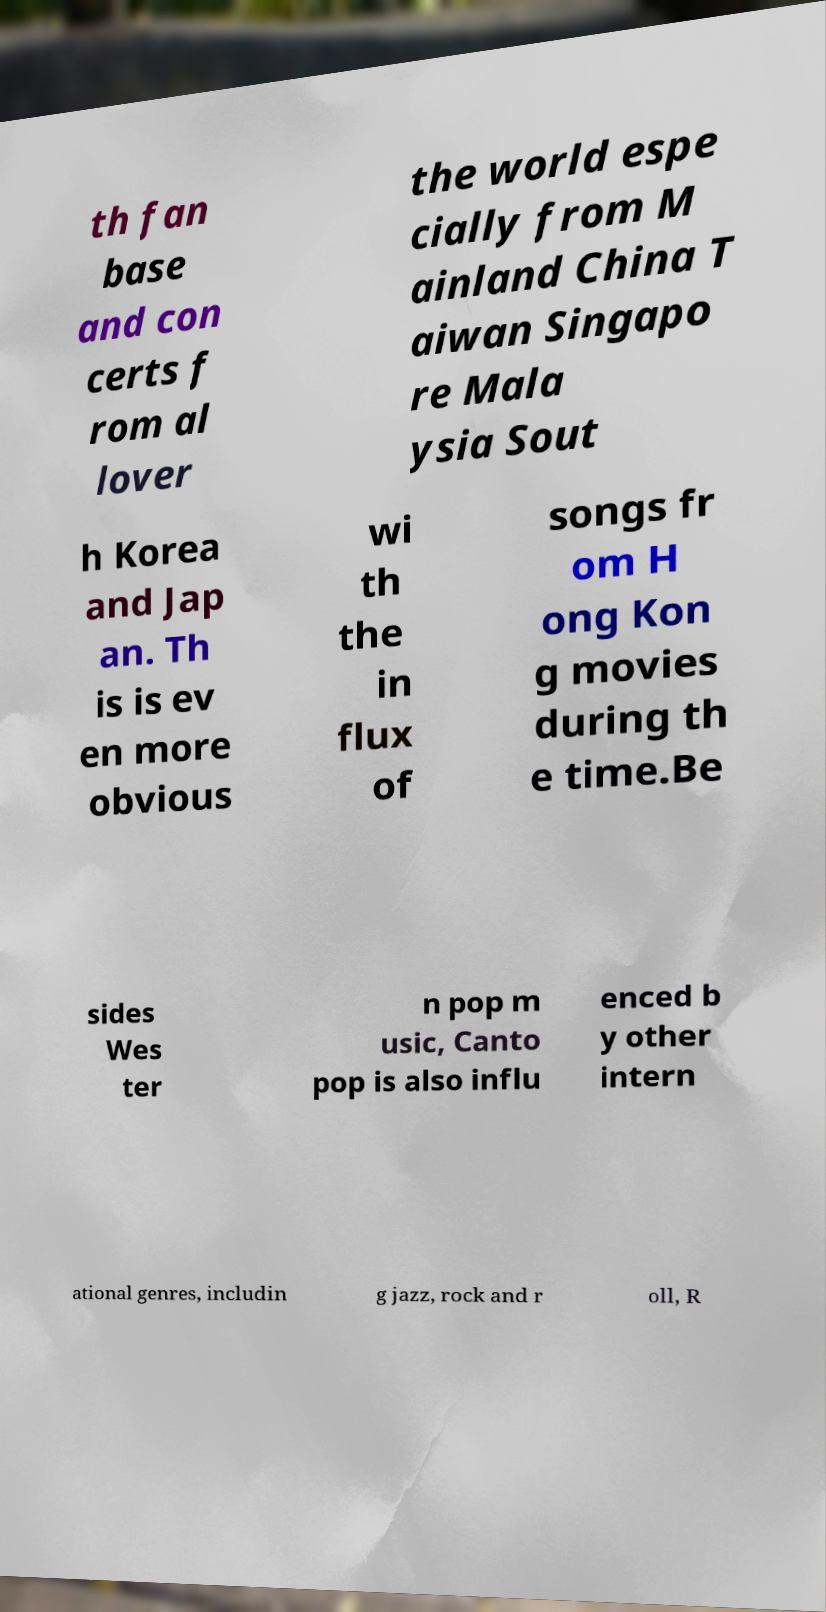What messages or text are displayed in this image? I need them in a readable, typed format. th fan base and con certs f rom al lover the world espe cially from M ainland China T aiwan Singapo re Mala ysia Sout h Korea and Jap an. Th is is ev en more obvious wi th the in flux of songs fr om H ong Kon g movies during th e time.Be sides Wes ter n pop m usic, Canto pop is also influ enced b y other intern ational genres, includin g jazz, rock and r oll, R 